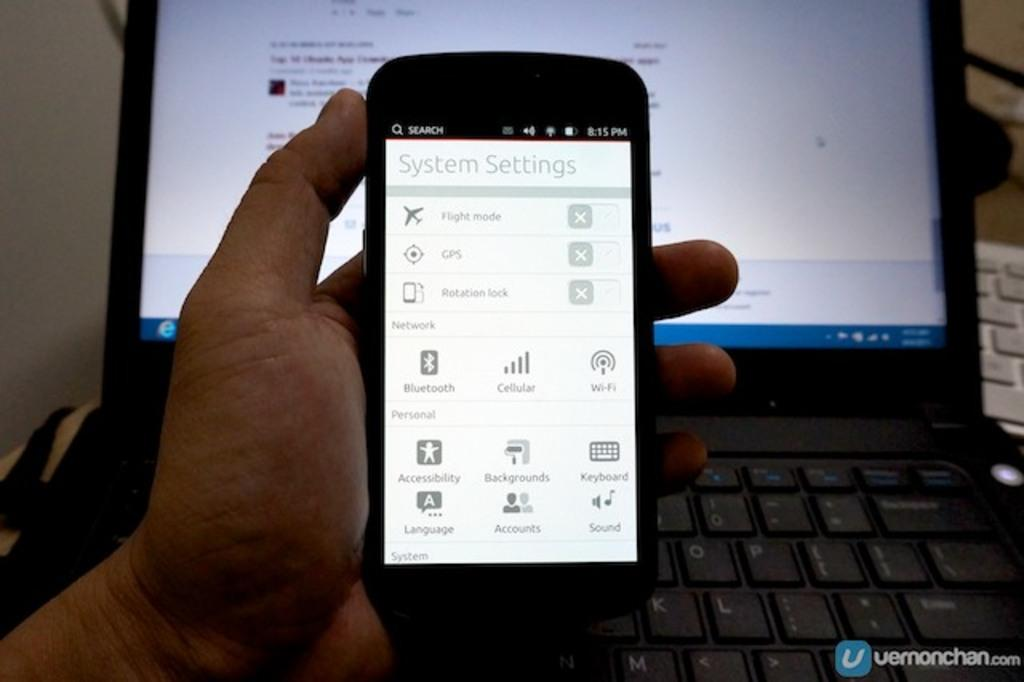<image>
Provide a brief description of the given image. hand holding cellphone on the system settings screen and a laptop in the background 